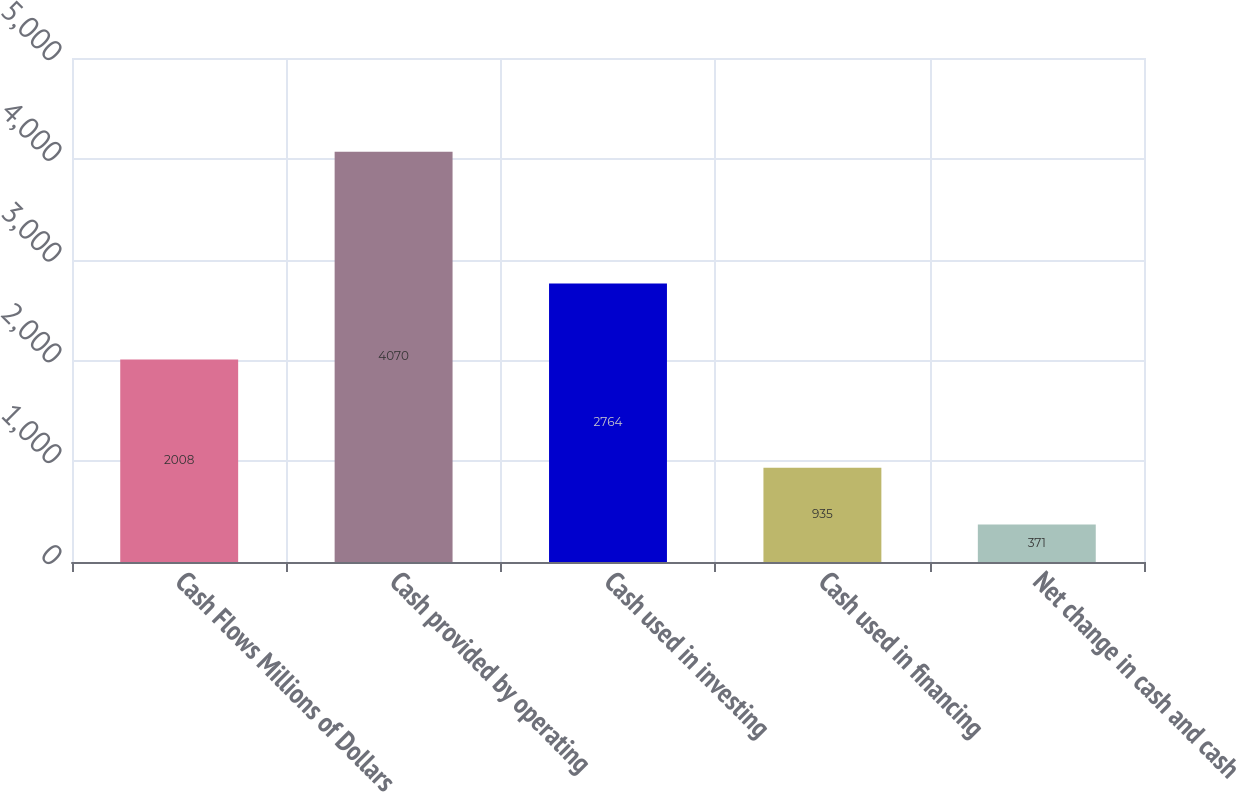Convert chart to OTSL. <chart><loc_0><loc_0><loc_500><loc_500><bar_chart><fcel>Cash Flows Millions of Dollars<fcel>Cash provided by operating<fcel>Cash used in investing<fcel>Cash used in financing<fcel>Net change in cash and cash<nl><fcel>2008<fcel>4070<fcel>2764<fcel>935<fcel>371<nl></chart> 